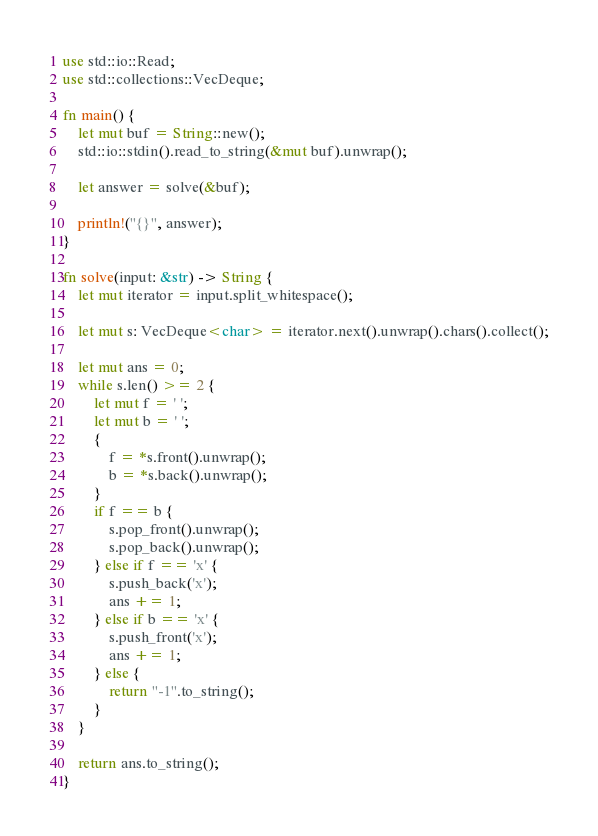Convert code to text. <code><loc_0><loc_0><loc_500><loc_500><_Rust_>use std::io::Read;
use std::collections::VecDeque;

fn main() {
    let mut buf = String::new();
    std::io::stdin().read_to_string(&mut buf).unwrap();

    let answer = solve(&buf);

    println!("{}", answer);
}

fn solve(input: &str) -> String {
    let mut iterator = input.split_whitespace();

    let mut s: VecDeque<char> = iterator.next().unwrap().chars().collect();

    let mut ans = 0;
    while s.len() >= 2 {
        let mut f = ' ';
        let mut b = ' ';
        {
            f = *s.front().unwrap();
            b = *s.back().unwrap();
        }
        if f == b {
            s.pop_front().unwrap();
            s.pop_back().unwrap();
        } else if f == 'x' {
            s.push_back('x');
            ans += 1;
        } else if b == 'x' {
            s.push_front('x');
            ans += 1;
        } else {
            return "-1".to_string();
        }
    }

    return ans.to_string();
}
</code> 